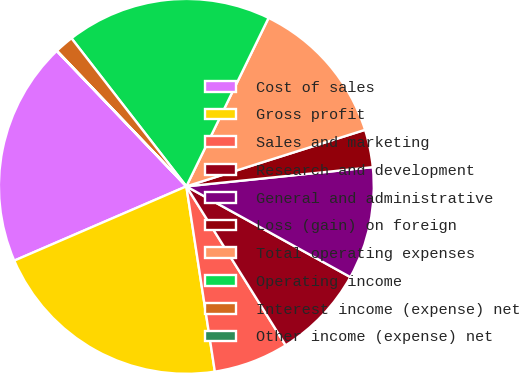Convert chart. <chart><loc_0><loc_0><loc_500><loc_500><pie_chart><fcel>Cost of sales<fcel>Gross profit<fcel>Sales and marketing<fcel>Research and development<fcel>General and administrative<fcel>Loss (gain) on foreign<fcel>Total operating expenses<fcel>Operating income<fcel>Interest income (expense) net<fcel>Other income (expense) net<nl><fcel>19.34%<fcel>20.95%<fcel>6.46%<fcel>8.07%<fcel>9.68%<fcel>3.24%<fcel>12.9%<fcel>17.73%<fcel>1.63%<fcel>0.02%<nl></chart> 